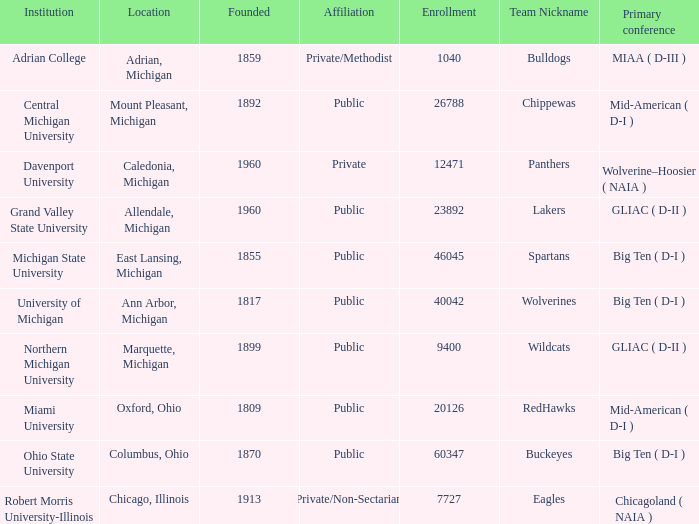How many major conferences occurred in allendale, michigan? 1.0. 